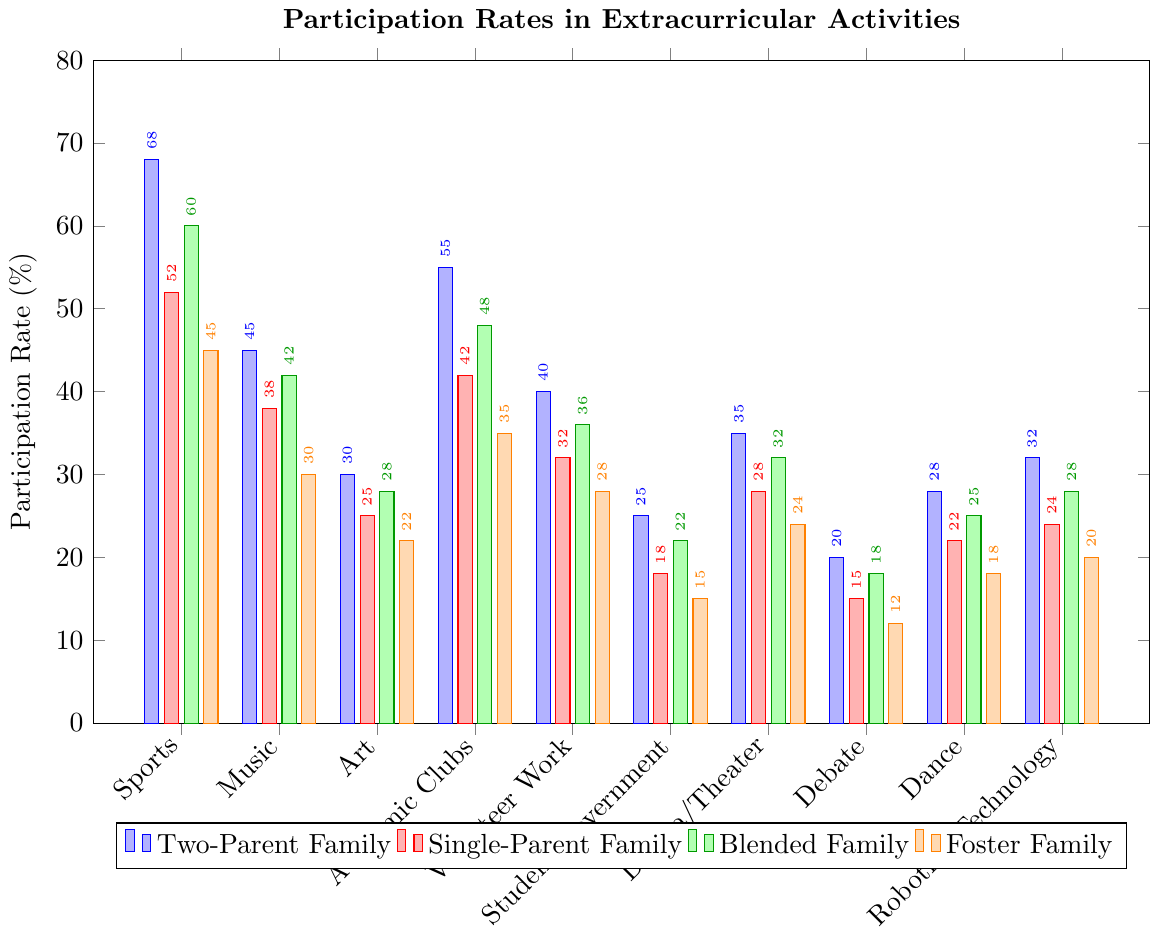What is the participation rate in sports for foster families, and how does it compare to that of two-parent families? The figure shows that the participation rate in sports for foster families is 45%, whereas for two-parent families, it is 68%. Comparing these, we see that the participation rate in two-parent families is higher.
Answer: The participation rate for foster families in sports is 45%, and for two-parent families, it is 68%. The two-parent families have a higher participation rate Which family structure has the highest participation rate in music? By looking at the bar chart, we can compare the heights of the bars for music. The highest bar for music is associated with two-parent families, which indicates the highest participation rate.
Answer: Two-parent families What is the average participation rate in academic clubs across all family structures? To find the average, sum the participation rates for academic clubs (Two-Parent Family: 55%, Single-Parent Family: 42%, Blended Family: 48%, Foster Family: 35%) and divide by the number of groups: (55 + 42 + 48 + 35) / 4 = 180 / 4.
Answer: 45% What is the total participation rate for blended families in music, drama/theater, and robotics/technology? Add the participation rates for each activity: Music: 42%, Drama/Theater: 32%, Robotics/Technology: 28%. Sum these values: 42 + 32 + 28 = 102.
Answer: 102% Identify the activity with the lowest participation rate across all family structures. Look at the bars representing the participation rates for each activity across all family types. The activity with the shortest bar overall is Debate, with 20% in two-parent families and lower in other family structures.
Answer: Debate How does the participation rate in student government for blended families compare with that of foster families? The bar chart shows that the participation rate for student government in blended families is 22%, while in foster families, it is 15%. This indicates that blended families have a higher participation rate than foster families in student government.
Answer: Blended families have a higher rate What is the difference between the highest and lowest participation rates in art among all family types? Identify the highest and lowest values for art from the chart: 
- Highest: Two-Parent Family (30%)
- Lowest: Foster Family (22%)
Calculate the difference: 30% - 22% = 8%.
Answer: 8% Which family structure has the highest variation in participation rates across the different activities? Calculate the range (difference between the maximum and minimum values) for each family structure:
- Two-Parent: max 68, min 20; 68 - 20 = 48
- Single-Parent: max 52, min 15; 52 - 15 = 37
- Blended: max 60, min 18; 60 - 18 = 42
- Foster: max 45, min 12; 45 - 12 = 33
The family structure with the highest variation is Two-Parent Family.
Answer: Two-Parent Family 